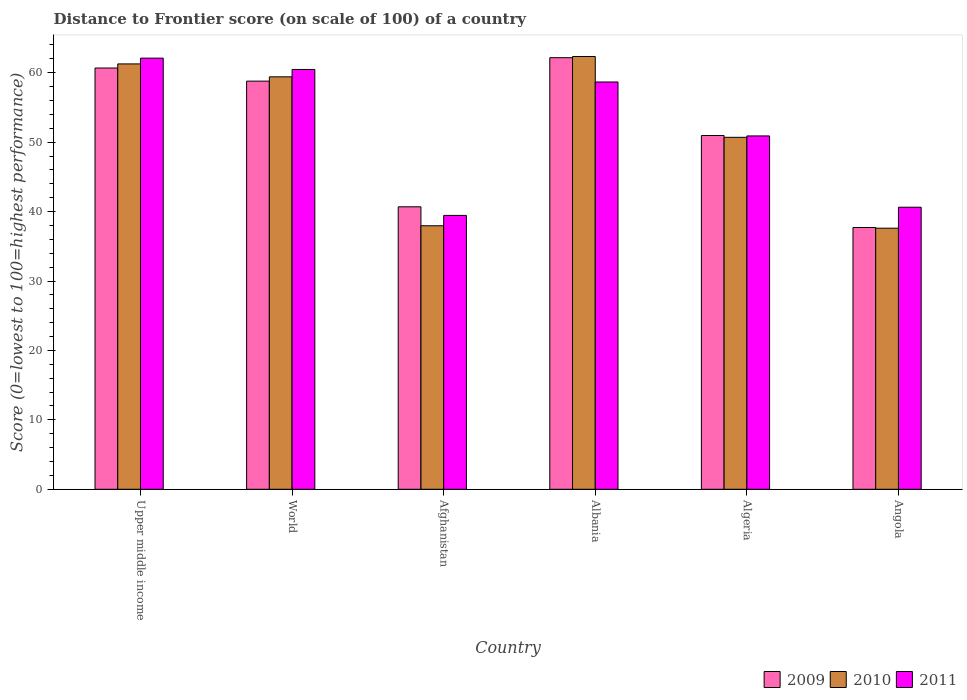How many groups of bars are there?
Keep it short and to the point. 6. How many bars are there on the 3rd tick from the left?
Your answer should be very brief. 3. What is the label of the 1st group of bars from the left?
Ensure brevity in your answer.  Upper middle income. What is the distance to frontier score of in 2011 in Albania?
Make the answer very short. 58.67. Across all countries, what is the maximum distance to frontier score of in 2011?
Offer a terse response. 62.11. Across all countries, what is the minimum distance to frontier score of in 2011?
Give a very brief answer. 39.45. In which country was the distance to frontier score of in 2011 maximum?
Your response must be concise. Upper middle income. In which country was the distance to frontier score of in 2009 minimum?
Ensure brevity in your answer.  Angola. What is the total distance to frontier score of in 2010 in the graph?
Ensure brevity in your answer.  309.3. What is the difference between the distance to frontier score of in 2009 in Afghanistan and that in Angola?
Offer a terse response. 2.98. What is the difference between the distance to frontier score of in 2009 in Angola and the distance to frontier score of in 2010 in Afghanistan?
Give a very brief answer. -0.25. What is the average distance to frontier score of in 2010 per country?
Your answer should be compact. 51.55. What is the difference between the distance to frontier score of of/in 2010 and distance to frontier score of of/in 2011 in Albania?
Your answer should be very brief. 3.67. What is the ratio of the distance to frontier score of in 2011 in Afghanistan to that in Algeria?
Offer a very short reply. 0.78. Is the distance to frontier score of in 2009 in Albania less than that in World?
Offer a terse response. No. What is the difference between the highest and the second highest distance to frontier score of in 2009?
Your response must be concise. -1.89. What is the difference between the highest and the lowest distance to frontier score of in 2011?
Your answer should be very brief. 22.66. In how many countries, is the distance to frontier score of in 2009 greater than the average distance to frontier score of in 2009 taken over all countries?
Keep it short and to the point. 3. Is the sum of the distance to frontier score of in 2011 in Angola and Upper middle income greater than the maximum distance to frontier score of in 2010 across all countries?
Your response must be concise. Yes. What does the 2nd bar from the left in Algeria represents?
Make the answer very short. 2010. Is it the case that in every country, the sum of the distance to frontier score of in 2010 and distance to frontier score of in 2009 is greater than the distance to frontier score of in 2011?
Provide a short and direct response. Yes. What is the difference between two consecutive major ticks on the Y-axis?
Your response must be concise. 10. Are the values on the major ticks of Y-axis written in scientific E-notation?
Offer a very short reply. No. How many legend labels are there?
Make the answer very short. 3. How are the legend labels stacked?
Keep it short and to the point. Horizontal. What is the title of the graph?
Make the answer very short. Distance to Frontier score (on scale of 100) of a country. Does "1995" appear as one of the legend labels in the graph?
Provide a succinct answer. No. What is the label or title of the Y-axis?
Keep it short and to the point. Score (0=lowest to 100=highest performance). What is the Score (0=lowest to 100=highest performance) in 2009 in Upper middle income?
Give a very brief answer. 60.68. What is the Score (0=lowest to 100=highest performance) of 2010 in Upper middle income?
Give a very brief answer. 61.27. What is the Score (0=lowest to 100=highest performance) in 2011 in Upper middle income?
Provide a succinct answer. 62.11. What is the Score (0=lowest to 100=highest performance) in 2009 in World?
Ensure brevity in your answer.  58.79. What is the Score (0=lowest to 100=highest performance) of 2010 in World?
Provide a succinct answer. 59.41. What is the Score (0=lowest to 100=highest performance) in 2011 in World?
Your response must be concise. 60.47. What is the Score (0=lowest to 100=highest performance) of 2009 in Afghanistan?
Your response must be concise. 40.69. What is the Score (0=lowest to 100=highest performance) in 2010 in Afghanistan?
Provide a succinct answer. 37.96. What is the Score (0=lowest to 100=highest performance) of 2011 in Afghanistan?
Give a very brief answer. 39.45. What is the Score (0=lowest to 100=highest performance) in 2009 in Albania?
Keep it short and to the point. 62.17. What is the Score (0=lowest to 100=highest performance) of 2010 in Albania?
Provide a short and direct response. 62.34. What is the Score (0=lowest to 100=highest performance) in 2011 in Albania?
Keep it short and to the point. 58.67. What is the Score (0=lowest to 100=highest performance) in 2009 in Algeria?
Give a very brief answer. 50.96. What is the Score (0=lowest to 100=highest performance) of 2010 in Algeria?
Provide a succinct answer. 50.7. What is the Score (0=lowest to 100=highest performance) of 2011 in Algeria?
Your response must be concise. 50.9. What is the Score (0=lowest to 100=highest performance) of 2009 in Angola?
Offer a terse response. 37.71. What is the Score (0=lowest to 100=highest performance) of 2010 in Angola?
Ensure brevity in your answer.  37.61. What is the Score (0=lowest to 100=highest performance) of 2011 in Angola?
Provide a succinct answer. 40.63. Across all countries, what is the maximum Score (0=lowest to 100=highest performance) of 2009?
Offer a terse response. 62.17. Across all countries, what is the maximum Score (0=lowest to 100=highest performance) in 2010?
Provide a succinct answer. 62.34. Across all countries, what is the maximum Score (0=lowest to 100=highest performance) in 2011?
Offer a very short reply. 62.11. Across all countries, what is the minimum Score (0=lowest to 100=highest performance) in 2009?
Provide a short and direct response. 37.71. Across all countries, what is the minimum Score (0=lowest to 100=highest performance) of 2010?
Your response must be concise. 37.61. Across all countries, what is the minimum Score (0=lowest to 100=highest performance) of 2011?
Make the answer very short. 39.45. What is the total Score (0=lowest to 100=highest performance) of 2009 in the graph?
Provide a short and direct response. 311.01. What is the total Score (0=lowest to 100=highest performance) of 2010 in the graph?
Offer a very short reply. 309.3. What is the total Score (0=lowest to 100=highest performance) in 2011 in the graph?
Give a very brief answer. 312.23. What is the difference between the Score (0=lowest to 100=highest performance) in 2009 in Upper middle income and that in World?
Provide a succinct answer. 1.89. What is the difference between the Score (0=lowest to 100=highest performance) of 2010 in Upper middle income and that in World?
Provide a short and direct response. 1.86. What is the difference between the Score (0=lowest to 100=highest performance) of 2011 in Upper middle income and that in World?
Your answer should be compact. 1.63. What is the difference between the Score (0=lowest to 100=highest performance) of 2009 in Upper middle income and that in Afghanistan?
Offer a very short reply. 19.99. What is the difference between the Score (0=lowest to 100=highest performance) in 2010 in Upper middle income and that in Afghanistan?
Ensure brevity in your answer.  23.31. What is the difference between the Score (0=lowest to 100=highest performance) in 2011 in Upper middle income and that in Afghanistan?
Offer a very short reply. 22.66. What is the difference between the Score (0=lowest to 100=highest performance) of 2009 in Upper middle income and that in Albania?
Your response must be concise. -1.49. What is the difference between the Score (0=lowest to 100=highest performance) in 2010 in Upper middle income and that in Albania?
Your answer should be very brief. -1.07. What is the difference between the Score (0=lowest to 100=highest performance) in 2011 in Upper middle income and that in Albania?
Make the answer very short. 3.44. What is the difference between the Score (0=lowest to 100=highest performance) of 2009 in Upper middle income and that in Algeria?
Ensure brevity in your answer.  9.72. What is the difference between the Score (0=lowest to 100=highest performance) in 2010 in Upper middle income and that in Algeria?
Your answer should be compact. 10.57. What is the difference between the Score (0=lowest to 100=highest performance) of 2011 in Upper middle income and that in Algeria?
Provide a short and direct response. 11.21. What is the difference between the Score (0=lowest to 100=highest performance) of 2009 in Upper middle income and that in Angola?
Provide a succinct answer. 22.97. What is the difference between the Score (0=lowest to 100=highest performance) of 2010 in Upper middle income and that in Angola?
Offer a terse response. 23.66. What is the difference between the Score (0=lowest to 100=highest performance) of 2011 in Upper middle income and that in Angola?
Your answer should be compact. 21.48. What is the difference between the Score (0=lowest to 100=highest performance) in 2009 in World and that in Afghanistan?
Offer a very short reply. 18.1. What is the difference between the Score (0=lowest to 100=highest performance) of 2010 in World and that in Afghanistan?
Keep it short and to the point. 21.45. What is the difference between the Score (0=lowest to 100=highest performance) in 2011 in World and that in Afghanistan?
Your answer should be compact. 21.02. What is the difference between the Score (0=lowest to 100=highest performance) in 2009 in World and that in Albania?
Make the answer very short. -3.38. What is the difference between the Score (0=lowest to 100=highest performance) in 2010 in World and that in Albania?
Provide a succinct answer. -2.93. What is the difference between the Score (0=lowest to 100=highest performance) of 2011 in World and that in Albania?
Make the answer very short. 1.8. What is the difference between the Score (0=lowest to 100=highest performance) of 2009 in World and that in Algeria?
Keep it short and to the point. 7.83. What is the difference between the Score (0=lowest to 100=highest performance) of 2010 in World and that in Algeria?
Offer a terse response. 8.71. What is the difference between the Score (0=lowest to 100=highest performance) in 2011 in World and that in Algeria?
Offer a terse response. 9.57. What is the difference between the Score (0=lowest to 100=highest performance) in 2009 in World and that in Angola?
Your answer should be very brief. 21.08. What is the difference between the Score (0=lowest to 100=highest performance) in 2010 in World and that in Angola?
Keep it short and to the point. 21.8. What is the difference between the Score (0=lowest to 100=highest performance) of 2011 in World and that in Angola?
Offer a terse response. 19.84. What is the difference between the Score (0=lowest to 100=highest performance) of 2009 in Afghanistan and that in Albania?
Offer a terse response. -21.48. What is the difference between the Score (0=lowest to 100=highest performance) in 2010 in Afghanistan and that in Albania?
Keep it short and to the point. -24.38. What is the difference between the Score (0=lowest to 100=highest performance) of 2011 in Afghanistan and that in Albania?
Keep it short and to the point. -19.22. What is the difference between the Score (0=lowest to 100=highest performance) in 2009 in Afghanistan and that in Algeria?
Make the answer very short. -10.27. What is the difference between the Score (0=lowest to 100=highest performance) in 2010 in Afghanistan and that in Algeria?
Provide a succinct answer. -12.74. What is the difference between the Score (0=lowest to 100=highest performance) of 2011 in Afghanistan and that in Algeria?
Provide a short and direct response. -11.45. What is the difference between the Score (0=lowest to 100=highest performance) in 2009 in Afghanistan and that in Angola?
Your response must be concise. 2.98. What is the difference between the Score (0=lowest to 100=highest performance) of 2010 in Afghanistan and that in Angola?
Provide a short and direct response. 0.35. What is the difference between the Score (0=lowest to 100=highest performance) in 2011 in Afghanistan and that in Angola?
Keep it short and to the point. -1.18. What is the difference between the Score (0=lowest to 100=highest performance) in 2009 in Albania and that in Algeria?
Make the answer very short. 11.21. What is the difference between the Score (0=lowest to 100=highest performance) of 2010 in Albania and that in Algeria?
Make the answer very short. 11.64. What is the difference between the Score (0=lowest to 100=highest performance) of 2011 in Albania and that in Algeria?
Make the answer very short. 7.77. What is the difference between the Score (0=lowest to 100=highest performance) of 2009 in Albania and that in Angola?
Provide a short and direct response. 24.46. What is the difference between the Score (0=lowest to 100=highest performance) in 2010 in Albania and that in Angola?
Give a very brief answer. 24.73. What is the difference between the Score (0=lowest to 100=highest performance) of 2011 in Albania and that in Angola?
Provide a short and direct response. 18.04. What is the difference between the Score (0=lowest to 100=highest performance) in 2009 in Algeria and that in Angola?
Make the answer very short. 13.25. What is the difference between the Score (0=lowest to 100=highest performance) in 2010 in Algeria and that in Angola?
Provide a succinct answer. 13.09. What is the difference between the Score (0=lowest to 100=highest performance) in 2011 in Algeria and that in Angola?
Make the answer very short. 10.27. What is the difference between the Score (0=lowest to 100=highest performance) in 2009 in Upper middle income and the Score (0=lowest to 100=highest performance) in 2010 in World?
Your response must be concise. 1.27. What is the difference between the Score (0=lowest to 100=highest performance) of 2009 in Upper middle income and the Score (0=lowest to 100=highest performance) of 2011 in World?
Your answer should be compact. 0.21. What is the difference between the Score (0=lowest to 100=highest performance) of 2010 in Upper middle income and the Score (0=lowest to 100=highest performance) of 2011 in World?
Your answer should be very brief. 0.8. What is the difference between the Score (0=lowest to 100=highest performance) in 2009 in Upper middle income and the Score (0=lowest to 100=highest performance) in 2010 in Afghanistan?
Your answer should be very brief. 22.72. What is the difference between the Score (0=lowest to 100=highest performance) in 2009 in Upper middle income and the Score (0=lowest to 100=highest performance) in 2011 in Afghanistan?
Offer a terse response. 21.23. What is the difference between the Score (0=lowest to 100=highest performance) of 2010 in Upper middle income and the Score (0=lowest to 100=highest performance) of 2011 in Afghanistan?
Make the answer very short. 21.82. What is the difference between the Score (0=lowest to 100=highest performance) of 2009 in Upper middle income and the Score (0=lowest to 100=highest performance) of 2010 in Albania?
Ensure brevity in your answer.  -1.66. What is the difference between the Score (0=lowest to 100=highest performance) in 2009 in Upper middle income and the Score (0=lowest to 100=highest performance) in 2011 in Albania?
Provide a short and direct response. 2.01. What is the difference between the Score (0=lowest to 100=highest performance) in 2010 in Upper middle income and the Score (0=lowest to 100=highest performance) in 2011 in Albania?
Your answer should be compact. 2.6. What is the difference between the Score (0=lowest to 100=highest performance) in 2009 in Upper middle income and the Score (0=lowest to 100=highest performance) in 2010 in Algeria?
Keep it short and to the point. 9.98. What is the difference between the Score (0=lowest to 100=highest performance) in 2009 in Upper middle income and the Score (0=lowest to 100=highest performance) in 2011 in Algeria?
Give a very brief answer. 9.78. What is the difference between the Score (0=lowest to 100=highest performance) in 2010 in Upper middle income and the Score (0=lowest to 100=highest performance) in 2011 in Algeria?
Provide a short and direct response. 10.37. What is the difference between the Score (0=lowest to 100=highest performance) in 2009 in Upper middle income and the Score (0=lowest to 100=highest performance) in 2010 in Angola?
Your response must be concise. 23.07. What is the difference between the Score (0=lowest to 100=highest performance) in 2009 in Upper middle income and the Score (0=lowest to 100=highest performance) in 2011 in Angola?
Keep it short and to the point. 20.05. What is the difference between the Score (0=lowest to 100=highest performance) of 2010 in Upper middle income and the Score (0=lowest to 100=highest performance) of 2011 in Angola?
Provide a succinct answer. 20.64. What is the difference between the Score (0=lowest to 100=highest performance) of 2009 in World and the Score (0=lowest to 100=highest performance) of 2010 in Afghanistan?
Give a very brief answer. 20.83. What is the difference between the Score (0=lowest to 100=highest performance) of 2009 in World and the Score (0=lowest to 100=highest performance) of 2011 in Afghanistan?
Provide a succinct answer. 19.34. What is the difference between the Score (0=lowest to 100=highest performance) in 2010 in World and the Score (0=lowest to 100=highest performance) in 2011 in Afghanistan?
Ensure brevity in your answer.  19.96. What is the difference between the Score (0=lowest to 100=highest performance) in 2009 in World and the Score (0=lowest to 100=highest performance) in 2010 in Albania?
Make the answer very short. -3.55. What is the difference between the Score (0=lowest to 100=highest performance) in 2009 in World and the Score (0=lowest to 100=highest performance) in 2011 in Albania?
Your answer should be very brief. 0.12. What is the difference between the Score (0=lowest to 100=highest performance) in 2010 in World and the Score (0=lowest to 100=highest performance) in 2011 in Albania?
Ensure brevity in your answer.  0.74. What is the difference between the Score (0=lowest to 100=highest performance) of 2009 in World and the Score (0=lowest to 100=highest performance) of 2010 in Algeria?
Make the answer very short. 8.09. What is the difference between the Score (0=lowest to 100=highest performance) of 2009 in World and the Score (0=lowest to 100=highest performance) of 2011 in Algeria?
Offer a terse response. 7.89. What is the difference between the Score (0=lowest to 100=highest performance) of 2010 in World and the Score (0=lowest to 100=highest performance) of 2011 in Algeria?
Make the answer very short. 8.51. What is the difference between the Score (0=lowest to 100=highest performance) in 2009 in World and the Score (0=lowest to 100=highest performance) in 2010 in Angola?
Make the answer very short. 21.18. What is the difference between the Score (0=lowest to 100=highest performance) of 2009 in World and the Score (0=lowest to 100=highest performance) of 2011 in Angola?
Offer a very short reply. 18.16. What is the difference between the Score (0=lowest to 100=highest performance) of 2010 in World and the Score (0=lowest to 100=highest performance) of 2011 in Angola?
Make the answer very short. 18.78. What is the difference between the Score (0=lowest to 100=highest performance) in 2009 in Afghanistan and the Score (0=lowest to 100=highest performance) in 2010 in Albania?
Your response must be concise. -21.65. What is the difference between the Score (0=lowest to 100=highest performance) of 2009 in Afghanistan and the Score (0=lowest to 100=highest performance) of 2011 in Albania?
Give a very brief answer. -17.98. What is the difference between the Score (0=lowest to 100=highest performance) in 2010 in Afghanistan and the Score (0=lowest to 100=highest performance) in 2011 in Albania?
Your answer should be compact. -20.71. What is the difference between the Score (0=lowest to 100=highest performance) of 2009 in Afghanistan and the Score (0=lowest to 100=highest performance) of 2010 in Algeria?
Provide a short and direct response. -10.01. What is the difference between the Score (0=lowest to 100=highest performance) in 2009 in Afghanistan and the Score (0=lowest to 100=highest performance) in 2011 in Algeria?
Your response must be concise. -10.21. What is the difference between the Score (0=lowest to 100=highest performance) in 2010 in Afghanistan and the Score (0=lowest to 100=highest performance) in 2011 in Algeria?
Your answer should be very brief. -12.94. What is the difference between the Score (0=lowest to 100=highest performance) in 2009 in Afghanistan and the Score (0=lowest to 100=highest performance) in 2010 in Angola?
Your answer should be very brief. 3.08. What is the difference between the Score (0=lowest to 100=highest performance) in 2009 in Afghanistan and the Score (0=lowest to 100=highest performance) in 2011 in Angola?
Your answer should be very brief. 0.06. What is the difference between the Score (0=lowest to 100=highest performance) in 2010 in Afghanistan and the Score (0=lowest to 100=highest performance) in 2011 in Angola?
Give a very brief answer. -2.67. What is the difference between the Score (0=lowest to 100=highest performance) in 2009 in Albania and the Score (0=lowest to 100=highest performance) in 2010 in Algeria?
Offer a terse response. 11.47. What is the difference between the Score (0=lowest to 100=highest performance) of 2009 in Albania and the Score (0=lowest to 100=highest performance) of 2011 in Algeria?
Provide a short and direct response. 11.27. What is the difference between the Score (0=lowest to 100=highest performance) in 2010 in Albania and the Score (0=lowest to 100=highest performance) in 2011 in Algeria?
Provide a succinct answer. 11.44. What is the difference between the Score (0=lowest to 100=highest performance) in 2009 in Albania and the Score (0=lowest to 100=highest performance) in 2010 in Angola?
Ensure brevity in your answer.  24.56. What is the difference between the Score (0=lowest to 100=highest performance) in 2009 in Albania and the Score (0=lowest to 100=highest performance) in 2011 in Angola?
Make the answer very short. 21.54. What is the difference between the Score (0=lowest to 100=highest performance) in 2010 in Albania and the Score (0=lowest to 100=highest performance) in 2011 in Angola?
Give a very brief answer. 21.71. What is the difference between the Score (0=lowest to 100=highest performance) of 2009 in Algeria and the Score (0=lowest to 100=highest performance) of 2010 in Angola?
Give a very brief answer. 13.35. What is the difference between the Score (0=lowest to 100=highest performance) of 2009 in Algeria and the Score (0=lowest to 100=highest performance) of 2011 in Angola?
Keep it short and to the point. 10.33. What is the difference between the Score (0=lowest to 100=highest performance) in 2010 in Algeria and the Score (0=lowest to 100=highest performance) in 2011 in Angola?
Your answer should be compact. 10.07. What is the average Score (0=lowest to 100=highest performance) in 2009 per country?
Your answer should be compact. 51.83. What is the average Score (0=lowest to 100=highest performance) of 2010 per country?
Your answer should be compact. 51.55. What is the average Score (0=lowest to 100=highest performance) in 2011 per country?
Your response must be concise. 52.04. What is the difference between the Score (0=lowest to 100=highest performance) in 2009 and Score (0=lowest to 100=highest performance) in 2010 in Upper middle income?
Ensure brevity in your answer.  -0.59. What is the difference between the Score (0=lowest to 100=highest performance) of 2009 and Score (0=lowest to 100=highest performance) of 2011 in Upper middle income?
Give a very brief answer. -1.42. What is the difference between the Score (0=lowest to 100=highest performance) of 2010 and Score (0=lowest to 100=highest performance) of 2011 in Upper middle income?
Provide a short and direct response. -0.83. What is the difference between the Score (0=lowest to 100=highest performance) in 2009 and Score (0=lowest to 100=highest performance) in 2010 in World?
Give a very brief answer. -0.62. What is the difference between the Score (0=lowest to 100=highest performance) in 2009 and Score (0=lowest to 100=highest performance) in 2011 in World?
Offer a terse response. -1.68. What is the difference between the Score (0=lowest to 100=highest performance) in 2010 and Score (0=lowest to 100=highest performance) in 2011 in World?
Provide a short and direct response. -1.06. What is the difference between the Score (0=lowest to 100=highest performance) of 2009 and Score (0=lowest to 100=highest performance) of 2010 in Afghanistan?
Ensure brevity in your answer.  2.73. What is the difference between the Score (0=lowest to 100=highest performance) in 2009 and Score (0=lowest to 100=highest performance) in 2011 in Afghanistan?
Your answer should be compact. 1.24. What is the difference between the Score (0=lowest to 100=highest performance) in 2010 and Score (0=lowest to 100=highest performance) in 2011 in Afghanistan?
Your answer should be compact. -1.49. What is the difference between the Score (0=lowest to 100=highest performance) of 2009 and Score (0=lowest to 100=highest performance) of 2010 in Albania?
Offer a terse response. -0.17. What is the difference between the Score (0=lowest to 100=highest performance) in 2010 and Score (0=lowest to 100=highest performance) in 2011 in Albania?
Your response must be concise. 3.67. What is the difference between the Score (0=lowest to 100=highest performance) of 2009 and Score (0=lowest to 100=highest performance) of 2010 in Algeria?
Offer a very short reply. 0.26. What is the difference between the Score (0=lowest to 100=highest performance) of 2009 and Score (0=lowest to 100=highest performance) of 2011 in Algeria?
Give a very brief answer. 0.06. What is the difference between the Score (0=lowest to 100=highest performance) of 2010 and Score (0=lowest to 100=highest performance) of 2011 in Algeria?
Your answer should be compact. -0.2. What is the difference between the Score (0=lowest to 100=highest performance) of 2009 and Score (0=lowest to 100=highest performance) of 2010 in Angola?
Your response must be concise. 0.1. What is the difference between the Score (0=lowest to 100=highest performance) in 2009 and Score (0=lowest to 100=highest performance) in 2011 in Angola?
Make the answer very short. -2.92. What is the difference between the Score (0=lowest to 100=highest performance) of 2010 and Score (0=lowest to 100=highest performance) of 2011 in Angola?
Ensure brevity in your answer.  -3.02. What is the ratio of the Score (0=lowest to 100=highest performance) in 2009 in Upper middle income to that in World?
Your response must be concise. 1.03. What is the ratio of the Score (0=lowest to 100=highest performance) of 2010 in Upper middle income to that in World?
Ensure brevity in your answer.  1.03. What is the ratio of the Score (0=lowest to 100=highest performance) in 2009 in Upper middle income to that in Afghanistan?
Your answer should be compact. 1.49. What is the ratio of the Score (0=lowest to 100=highest performance) of 2010 in Upper middle income to that in Afghanistan?
Offer a very short reply. 1.61. What is the ratio of the Score (0=lowest to 100=highest performance) of 2011 in Upper middle income to that in Afghanistan?
Your answer should be compact. 1.57. What is the ratio of the Score (0=lowest to 100=highest performance) in 2009 in Upper middle income to that in Albania?
Your answer should be compact. 0.98. What is the ratio of the Score (0=lowest to 100=highest performance) of 2010 in Upper middle income to that in Albania?
Your answer should be very brief. 0.98. What is the ratio of the Score (0=lowest to 100=highest performance) of 2011 in Upper middle income to that in Albania?
Ensure brevity in your answer.  1.06. What is the ratio of the Score (0=lowest to 100=highest performance) of 2009 in Upper middle income to that in Algeria?
Give a very brief answer. 1.19. What is the ratio of the Score (0=lowest to 100=highest performance) of 2010 in Upper middle income to that in Algeria?
Offer a very short reply. 1.21. What is the ratio of the Score (0=lowest to 100=highest performance) of 2011 in Upper middle income to that in Algeria?
Give a very brief answer. 1.22. What is the ratio of the Score (0=lowest to 100=highest performance) in 2009 in Upper middle income to that in Angola?
Your response must be concise. 1.61. What is the ratio of the Score (0=lowest to 100=highest performance) in 2010 in Upper middle income to that in Angola?
Give a very brief answer. 1.63. What is the ratio of the Score (0=lowest to 100=highest performance) in 2011 in Upper middle income to that in Angola?
Make the answer very short. 1.53. What is the ratio of the Score (0=lowest to 100=highest performance) of 2009 in World to that in Afghanistan?
Your answer should be very brief. 1.44. What is the ratio of the Score (0=lowest to 100=highest performance) of 2010 in World to that in Afghanistan?
Your response must be concise. 1.57. What is the ratio of the Score (0=lowest to 100=highest performance) of 2011 in World to that in Afghanistan?
Offer a very short reply. 1.53. What is the ratio of the Score (0=lowest to 100=highest performance) of 2009 in World to that in Albania?
Keep it short and to the point. 0.95. What is the ratio of the Score (0=lowest to 100=highest performance) in 2010 in World to that in Albania?
Keep it short and to the point. 0.95. What is the ratio of the Score (0=lowest to 100=highest performance) of 2011 in World to that in Albania?
Ensure brevity in your answer.  1.03. What is the ratio of the Score (0=lowest to 100=highest performance) in 2009 in World to that in Algeria?
Your answer should be compact. 1.15. What is the ratio of the Score (0=lowest to 100=highest performance) of 2010 in World to that in Algeria?
Your answer should be compact. 1.17. What is the ratio of the Score (0=lowest to 100=highest performance) of 2011 in World to that in Algeria?
Offer a very short reply. 1.19. What is the ratio of the Score (0=lowest to 100=highest performance) in 2009 in World to that in Angola?
Your answer should be very brief. 1.56. What is the ratio of the Score (0=lowest to 100=highest performance) of 2010 in World to that in Angola?
Your answer should be very brief. 1.58. What is the ratio of the Score (0=lowest to 100=highest performance) of 2011 in World to that in Angola?
Your response must be concise. 1.49. What is the ratio of the Score (0=lowest to 100=highest performance) in 2009 in Afghanistan to that in Albania?
Provide a succinct answer. 0.65. What is the ratio of the Score (0=lowest to 100=highest performance) of 2010 in Afghanistan to that in Albania?
Provide a succinct answer. 0.61. What is the ratio of the Score (0=lowest to 100=highest performance) in 2011 in Afghanistan to that in Albania?
Provide a short and direct response. 0.67. What is the ratio of the Score (0=lowest to 100=highest performance) in 2009 in Afghanistan to that in Algeria?
Provide a short and direct response. 0.8. What is the ratio of the Score (0=lowest to 100=highest performance) in 2010 in Afghanistan to that in Algeria?
Provide a succinct answer. 0.75. What is the ratio of the Score (0=lowest to 100=highest performance) of 2011 in Afghanistan to that in Algeria?
Ensure brevity in your answer.  0.78. What is the ratio of the Score (0=lowest to 100=highest performance) of 2009 in Afghanistan to that in Angola?
Keep it short and to the point. 1.08. What is the ratio of the Score (0=lowest to 100=highest performance) of 2010 in Afghanistan to that in Angola?
Your answer should be compact. 1.01. What is the ratio of the Score (0=lowest to 100=highest performance) in 2009 in Albania to that in Algeria?
Provide a succinct answer. 1.22. What is the ratio of the Score (0=lowest to 100=highest performance) of 2010 in Albania to that in Algeria?
Give a very brief answer. 1.23. What is the ratio of the Score (0=lowest to 100=highest performance) of 2011 in Albania to that in Algeria?
Offer a terse response. 1.15. What is the ratio of the Score (0=lowest to 100=highest performance) in 2009 in Albania to that in Angola?
Keep it short and to the point. 1.65. What is the ratio of the Score (0=lowest to 100=highest performance) in 2010 in Albania to that in Angola?
Offer a very short reply. 1.66. What is the ratio of the Score (0=lowest to 100=highest performance) of 2011 in Albania to that in Angola?
Ensure brevity in your answer.  1.44. What is the ratio of the Score (0=lowest to 100=highest performance) in 2009 in Algeria to that in Angola?
Give a very brief answer. 1.35. What is the ratio of the Score (0=lowest to 100=highest performance) of 2010 in Algeria to that in Angola?
Provide a short and direct response. 1.35. What is the ratio of the Score (0=lowest to 100=highest performance) of 2011 in Algeria to that in Angola?
Make the answer very short. 1.25. What is the difference between the highest and the second highest Score (0=lowest to 100=highest performance) of 2009?
Give a very brief answer. 1.49. What is the difference between the highest and the second highest Score (0=lowest to 100=highest performance) of 2010?
Your answer should be compact. 1.07. What is the difference between the highest and the second highest Score (0=lowest to 100=highest performance) of 2011?
Offer a very short reply. 1.63. What is the difference between the highest and the lowest Score (0=lowest to 100=highest performance) in 2009?
Provide a succinct answer. 24.46. What is the difference between the highest and the lowest Score (0=lowest to 100=highest performance) of 2010?
Your response must be concise. 24.73. What is the difference between the highest and the lowest Score (0=lowest to 100=highest performance) in 2011?
Offer a very short reply. 22.66. 